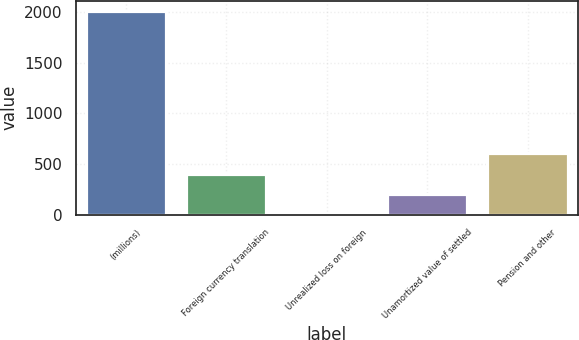Convert chart. <chart><loc_0><loc_0><loc_500><loc_500><bar_chart><fcel>(millions)<fcel>Foreign currency translation<fcel>Unrealized loss on foreign<fcel>Unamortized value of settled<fcel>Pension and other<nl><fcel>2012<fcel>403.68<fcel>1.6<fcel>202.64<fcel>604.72<nl></chart> 